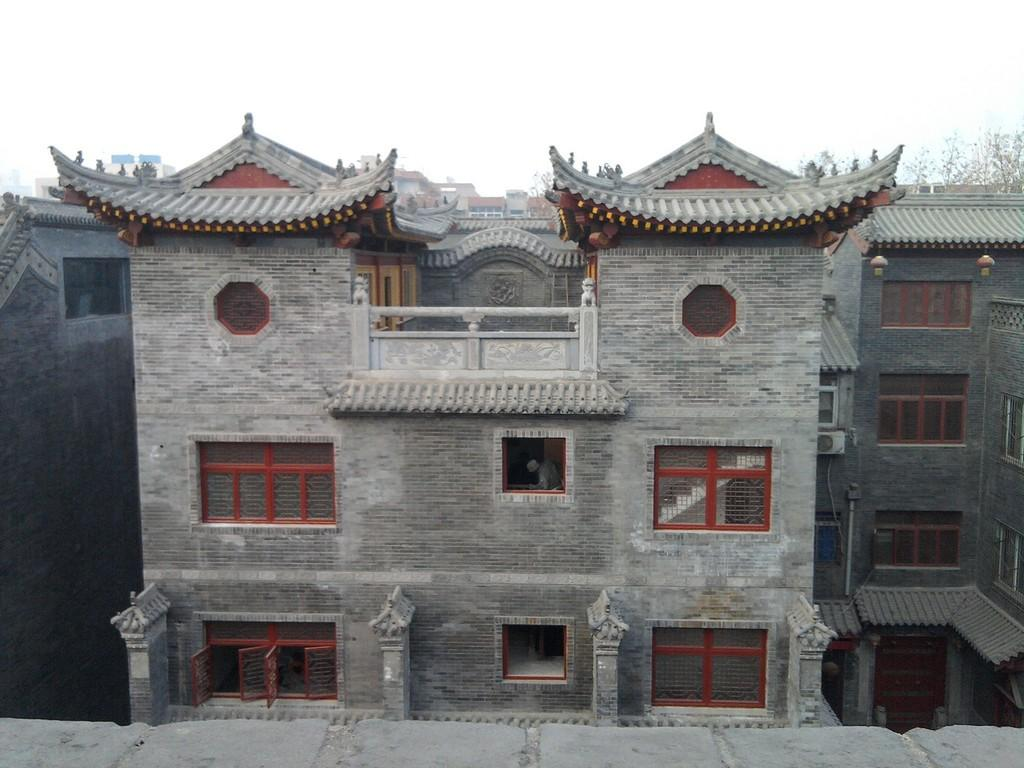What type of structures are present in the image? There are buildings with windows in the image. What can be seen in the background of the image? There are trees and the sky visible in the background of the image. What type of juice is being offered by the trees in the image? There is no juice present in the image, and the trees are not offering anything. 